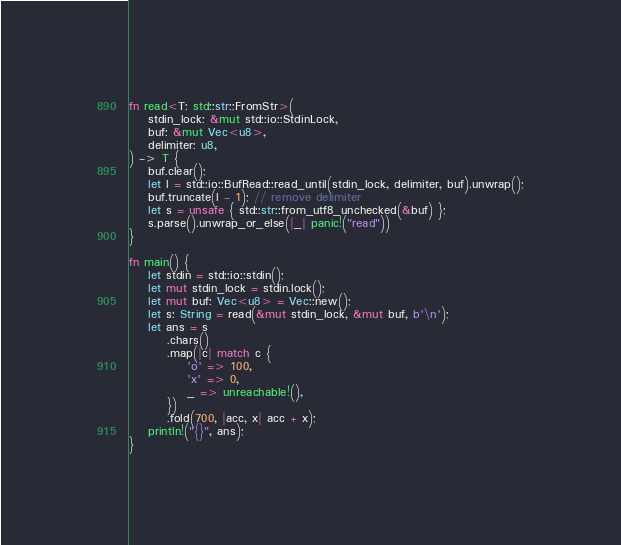<code> <loc_0><loc_0><loc_500><loc_500><_Rust_>fn read<T: std::str::FromStr>(
    stdin_lock: &mut std::io::StdinLock,
    buf: &mut Vec<u8>,
    delimiter: u8,
) -> T {
    buf.clear();
    let l = std::io::BufRead::read_until(stdin_lock, delimiter, buf).unwrap();
    buf.truncate(l - 1); // remove delimiter
    let s = unsafe { std::str::from_utf8_unchecked(&buf) };
    s.parse().unwrap_or_else(|_| panic!("read"))
}

fn main() {
    let stdin = std::io::stdin();
    let mut stdin_lock = stdin.lock();
    let mut buf: Vec<u8> = Vec::new();
    let s: String = read(&mut stdin_lock, &mut buf, b'\n');
    let ans = s
        .chars()
        .map(|c| match c {
            'o' => 100,
            'x' => 0,
            _ => unreachable!(),
        })
        .fold(700, |acc, x| acc + x);
    println!("{}", ans);
}
</code> 